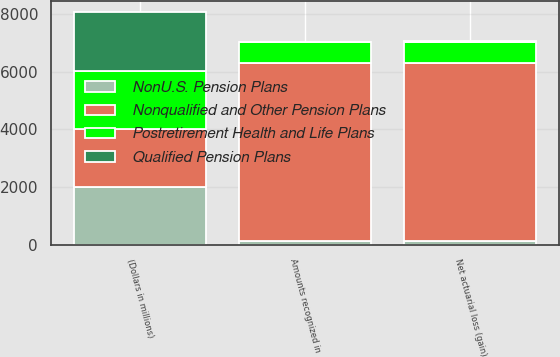Convert chart. <chart><loc_0><loc_0><loc_500><loc_500><stacked_bar_chart><ecel><fcel>(Dollars in millions)<fcel>Net actuarial loss (gain)<fcel>Amounts recognized in<nl><fcel>Nonqualified and Other Pension Plans<fcel>2012<fcel>6164<fcel>6164<nl><fcel>NonU.S. Pension Plans<fcel>2012<fcel>144<fcel>149<nl><fcel>Postretirement Health and Life Plans<fcel>2012<fcel>718<fcel>718<nl><fcel>Qualified Pension Plans<fcel>2012<fcel>28<fcel>1<nl></chart> 